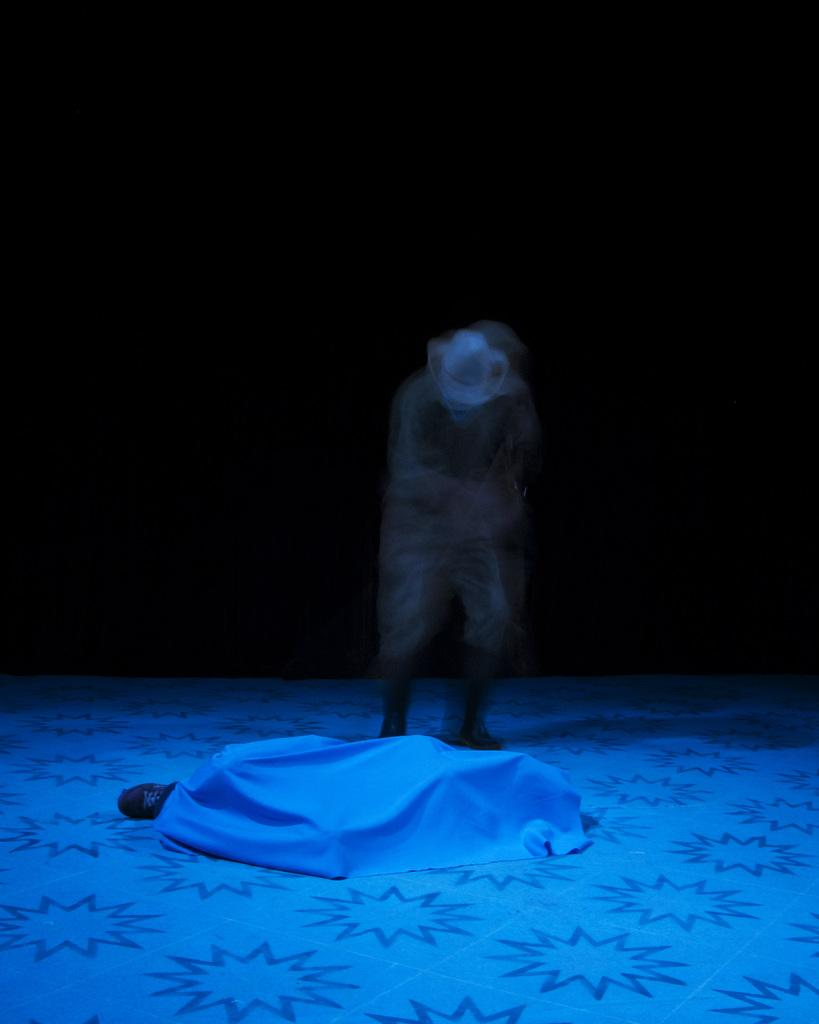How many people are present in the image? There are two people in the image. What are the positions of the people in the image? One person is standing, and the other person is lying on the floor. What is covering the person lying on the floor? The person lying on the floor is covered by a white bed sheet. What type of turkey is being prepared by the person standing in the image? There is no turkey present in the image, and the person standing is not preparing any food. What type of underwear is the person lying on the floor wearing? The person lying on the floor is covered by a white bed sheet, and their underwear is not visible in the image. 